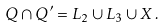<formula> <loc_0><loc_0><loc_500><loc_500>Q \cap Q ^ { \prime } = L _ { 2 } \cup L _ { 3 } \cup X \, .</formula> 